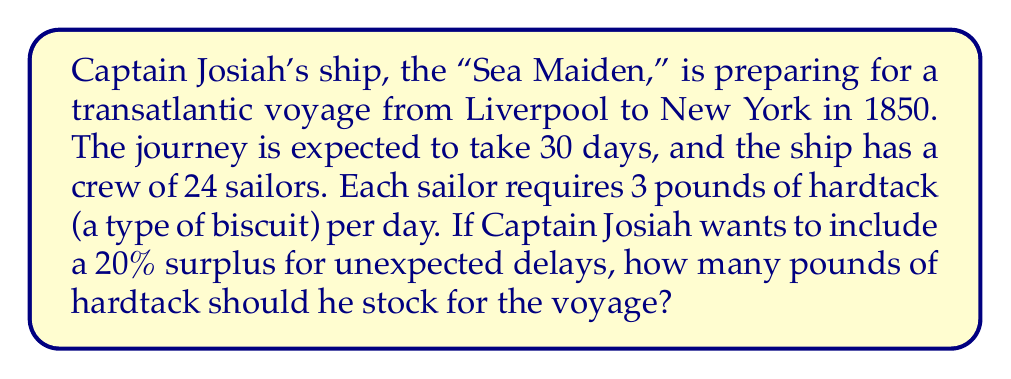Provide a solution to this math problem. Let's break this problem down step-by-step:

1. Calculate the basic daily requirement:
   $$ \text{Daily requirement} = \text{Number of sailors} \times \text{Pounds per sailor per day} $$
   $$ \text{Daily requirement} = 24 \times 3 = 72 \text{ pounds} $$

2. Calculate the total requirement for the expected journey duration:
   $$ \text{Total requirement} = \text{Daily requirement} \times \text{Number of days} $$
   $$ \text{Total requirement} = 72 \times 30 = 2,160 \text{ pounds} $$

3. Calculate the 20% surplus:
   $$ \text{Surplus} = \text{Total requirement} \times 20\% $$
   $$ \text{Surplus} = 2,160 \times 0.20 = 432 \text{ pounds} $$

4. Add the surplus to the total requirement:
   $$ \text{Total stock} = \text{Total requirement} + \text{Surplus} $$
   $$ \text{Total stock} = 2,160 + 432 = 2,592 \text{ pounds} $$

Therefore, Captain Josiah should stock 2,592 pounds of hardtack for the voyage.
Answer: 2,592 pounds of hardtack 